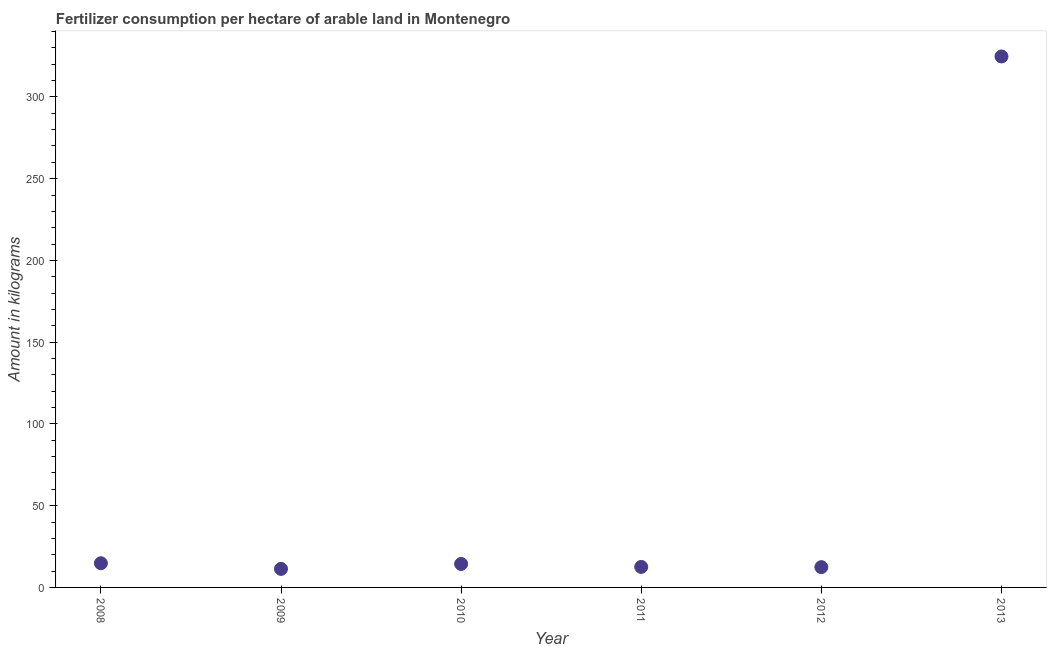What is the amount of fertilizer consumption in 2010?
Your answer should be very brief. 14.35. Across all years, what is the maximum amount of fertilizer consumption?
Ensure brevity in your answer.  324.74. Across all years, what is the minimum amount of fertilizer consumption?
Make the answer very short. 11.33. What is the sum of the amount of fertilizer consumption?
Provide a short and direct response. 390.18. What is the difference between the amount of fertilizer consumption in 2008 and 2010?
Your answer should be very brief. 0.44. What is the average amount of fertilizer consumption per year?
Provide a succinct answer. 65.03. What is the median amount of fertilizer consumption?
Keep it short and to the point. 13.45. What is the ratio of the amount of fertilizer consumption in 2012 to that in 2013?
Give a very brief answer. 0.04. Is the amount of fertilizer consumption in 2008 less than that in 2011?
Give a very brief answer. No. Is the difference between the amount of fertilizer consumption in 2011 and 2012 greater than the difference between any two years?
Ensure brevity in your answer.  No. What is the difference between the highest and the second highest amount of fertilizer consumption?
Provide a short and direct response. 309.95. Is the sum of the amount of fertilizer consumption in 2008 and 2011 greater than the maximum amount of fertilizer consumption across all years?
Your answer should be very brief. No. What is the difference between the highest and the lowest amount of fertilizer consumption?
Offer a very short reply. 313.41. In how many years, is the amount of fertilizer consumption greater than the average amount of fertilizer consumption taken over all years?
Provide a short and direct response. 1. Does the amount of fertilizer consumption monotonically increase over the years?
Your answer should be very brief. No. How many dotlines are there?
Your answer should be very brief. 1. How many years are there in the graph?
Give a very brief answer. 6. What is the title of the graph?
Give a very brief answer. Fertilizer consumption per hectare of arable land in Montenegro . What is the label or title of the X-axis?
Ensure brevity in your answer.  Year. What is the label or title of the Y-axis?
Your response must be concise. Amount in kilograms. What is the Amount in kilograms in 2008?
Provide a short and direct response. 14.79. What is the Amount in kilograms in 2009?
Your answer should be very brief. 11.33. What is the Amount in kilograms in 2010?
Offer a very short reply. 14.35. What is the Amount in kilograms in 2011?
Provide a short and direct response. 12.55. What is the Amount in kilograms in 2012?
Your answer should be compact. 12.41. What is the Amount in kilograms in 2013?
Offer a very short reply. 324.74. What is the difference between the Amount in kilograms in 2008 and 2009?
Provide a short and direct response. 3.46. What is the difference between the Amount in kilograms in 2008 and 2010?
Make the answer very short. 0.44. What is the difference between the Amount in kilograms in 2008 and 2011?
Your answer should be compact. 2.24. What is the difference between the Amount in kilograms in 2008 and 2012?
Provide a short and direct response. 2.38. What is the difference between the Amount in kilograms in 2008 and 2013?
Offer a terse response. -309.95. What is the difference between the Amount in kilograms in 2009 and 2010?
Make the answer very short. -3.03. What is the difference between the Amount in kilograms in 2009 and 2011?
Keep it short and to the point. -1.22. What is the difference between the Amount in kilograms in 2009 and 2012?
Your answer should be compact. -1.08. What is the difference between the Amount in kilograms in 2009 and 2013?
Offer a terse response. -313.41. What is the difference between the Amount in kilograms in 2010 and 2011?
Keep it short and to the point. 1.81. What is the difference between the Amount in kilograms in 2010 and 2012?
Give a very brief answer. 1.94. What is the difference between the Amount in kilograms in 2010 and 2013?
Offer a very short reply. -310.39. What is the difference between the Amount in kilograms in 2011 and 2012?
Provide a short and direct response. 0.14. What is the difference between the Amount in kilograms in 2011 and 2013?
Your answer should be very brief. -312.19. What is the difference between the Amount in kilograms in 2012 and 2013?
Offer a terse response. -312.33. What is the ratio of the Amount in kilograms in 2008 to that in 2009?
Your response must be concise. 1.31. What is the ratio of the Amount in kilograms in 2008 to that in 2011?
Keep it short and to the point. 1.18. What is the ratio of the Amount in kilograms in 2008 to that in 2012?
Make the answer very short. 1.19. What is the ratio of the Amount in kilograms in 2008 to that in 2013?
Give a very brief answer. 0.05. What is the ratio of the Amount in kilograms in 2009 to that in 2010?
Provide a short and direct response. 0.79. What is the ratio of the Amount in kilograms in 2009 to that in 2011?
Make the answer very short. 0.9. What is the ratio of the Amount in kilograms in 2009 to that in 2012?
Provide a short and direct response. 0.91. What is the ratio of the Amount in kilograms in 2009 to that in 2013?
Your answer should be compact. 0.04. What is the ratio of the Amount in kilograms in 2010 to that in 2011?
Your answer should be compact. 1.14. What is the ratio of the Amount in kilograms in 2010 to that in 2012?
Offer a very short reply. 1.16. What is the ratio of the Amount in kilograms in 2010 to that in 2013?
Keep it short and to the point. 0.04. What is the ratio of the Amount in kilograms in 2011 to that in 2013?
Provide a succinct answer. 0.04. What is the ratio of the Amount in kilograms in 2012 to that in 2013?
Your answer should be compact. 0.04. 